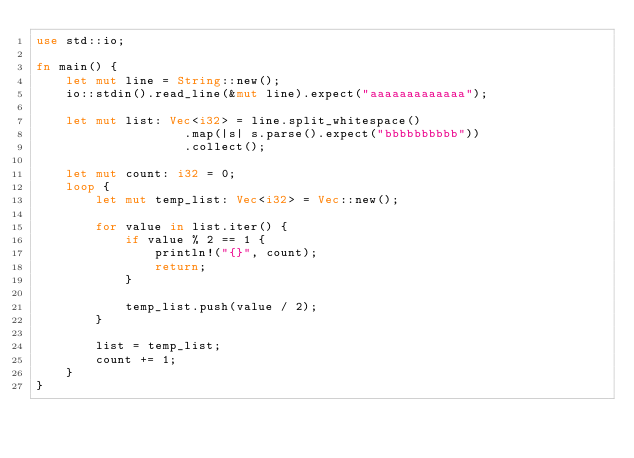Convert code to text. <code><loc_0><loc_0><loc_500><loc_500><_Rust_>use std::io;

fn main() {
    let mut line = String::new();
    io::stdin().read_line(&mut line).expect("aaaaaaaaaaaaa");

    let mut list: Vec<i32> = line.split_whitespace()
                    .map(|s| s.parse().expect("bbbbbbbbbb"))
                    .collect();

    let mut count: i32 = 0;
    loop {
        let mut temp_list: Vec<i32> = Vec::new();

        for value in list.iter() {
            if value % 2 == 1 {
                println!("{}", count);
                return;
            }

            temp_list.push(value / 2);
        }

        list = temp_list;
        count += 1;
    }
}
</code> 